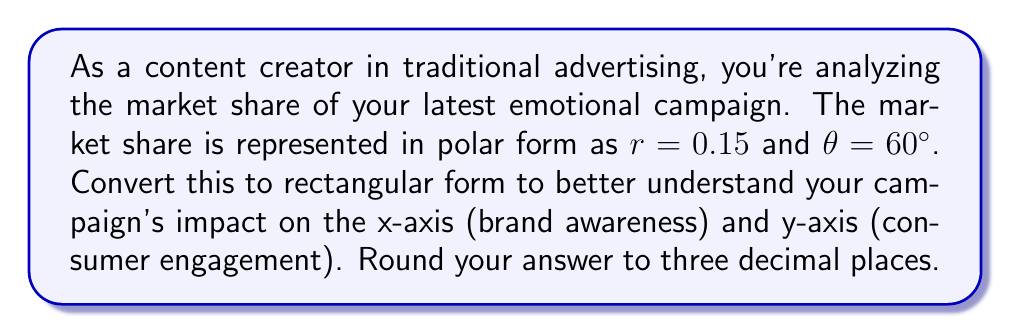Provide a solution to this math problem. To convert from polar form to rectangular form, we use the following formulas:

$x = r \cos(\theta)$
$y = r \sin(\theta)$

Where:
$r$ is the magnitude (in this case, the market share)
$\theta$ is the angle in radians

Step 1: Convert the angle from degrees to radians
$60° = \frac{60 \pi}{180} = \frac{\pi}{3}$ radians

Step 2: Calculate the x-coordinate (brand awareness)
$x = r \cos(\theta)$
$x = 0.15 \cos(\frac{\pi}{3})$
$x = 0.15 \cdot \frac{1}{2} = 0.075$

Step 3: Calculate the y-coordinate (consumer engagement)
$y = r \sin(\theta)$
$y = 0.15 \sin(\frac{\pi}{3})$
$y = 0.15 \cdot \frac{\sqrt{3}}{2} = 0.15 \cdot 0.866 = 0.1299$

Step 4: Round both coordinates to three decimal places
$x \approx 0.075$
$y \approx 0.130$

Therefore, the rectangular form is $(0.075, 0.130)$.
Answer: $(0.075, 0.130)$ 